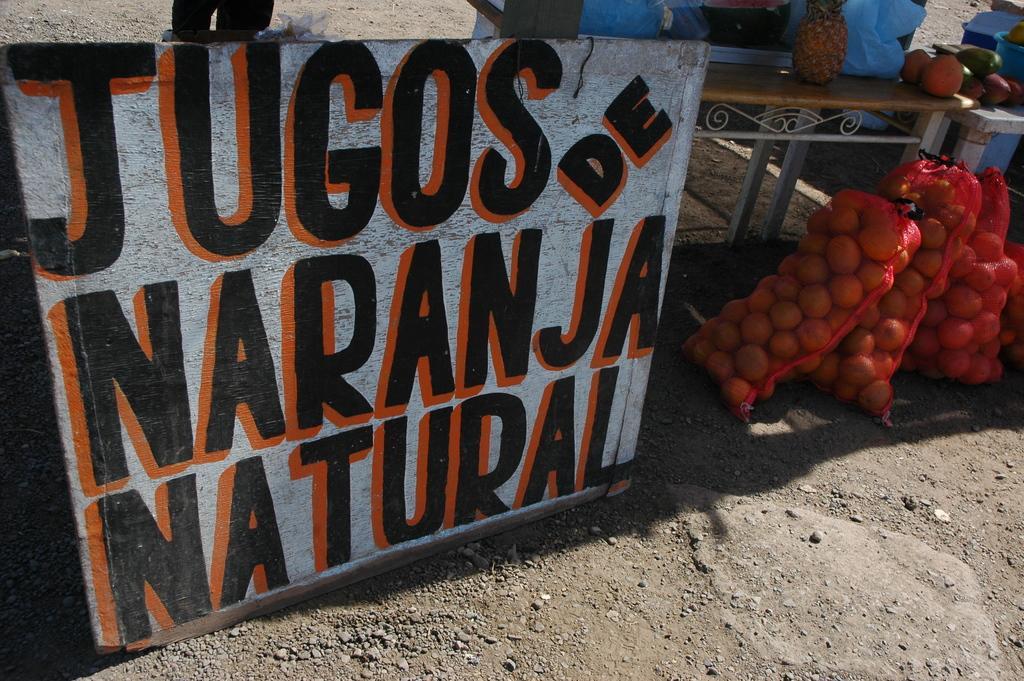Can you describe this image briefly? In this image I can see the ground, a board which is white, black and orange in color, few fruits in the bags which are on the ground. I can see a desk and on the desk I can see a pineapple and few other fruits. In the background I can see few other objects. 